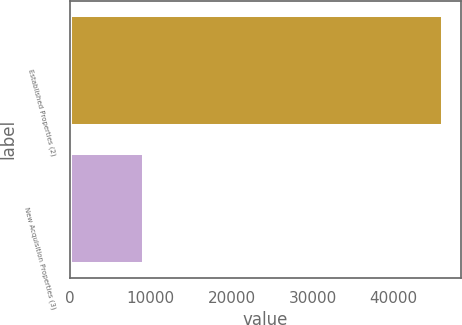Convert chart to OTSL. <chart><loc_0><loc_0><loc_500><loc_500><bar_chart><fcel>Established Properties (2)<fcel>New Acquisition Properties (3)<nl><fcel>46094<fcel>9194<nl></chart> 